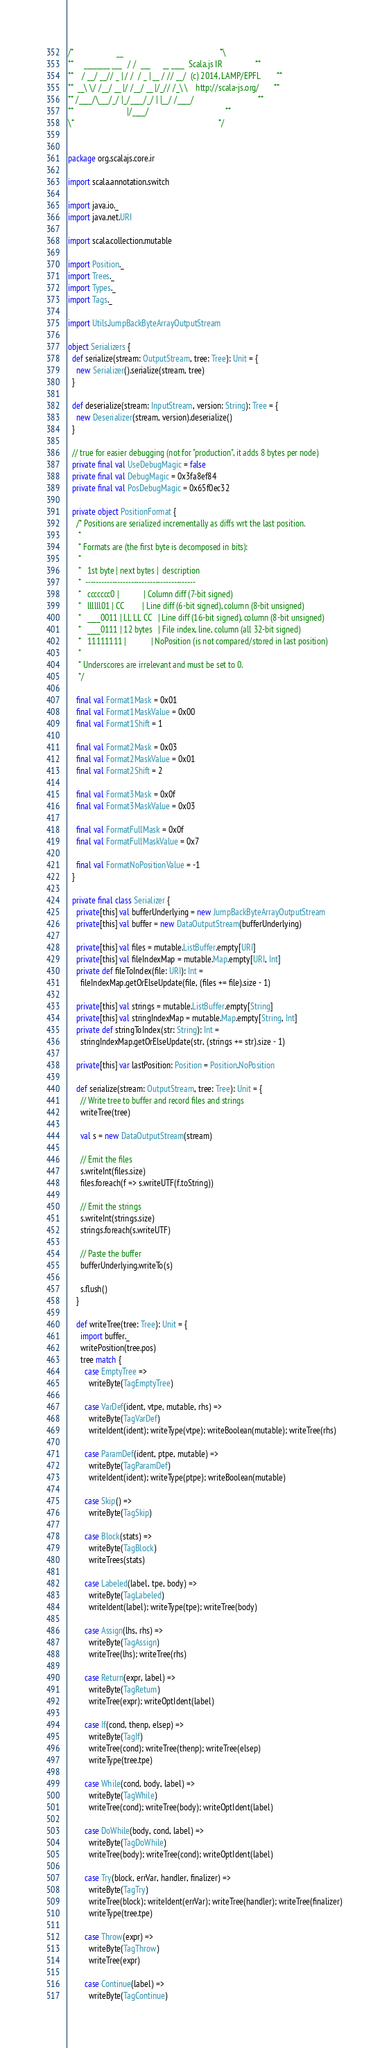<code> <loc_0><loc_0><loc_500><loc_500><_Scala_>/*                     __                                               *\
**     ________ ___   / /  ___      __ ____  Scala.js IR                **
**    / __/ __// _ | / /  / _ | __ / // __/  (c) 2014, LAMP/EPFL        **
**  __\ \/ /__/ __ |/ /__/ __ |/_// /_\ \    http://scala-js.org/       **
** /____/\___/_/ |_/____/_/ | |__/ /____/                               **
**                          |/____/                                     **
\*                                                                      */


package org.scalajs.core.ir

import scala.annotation.switch

import java.io._
import java.net.URI

import scala.collection.mutable

import Position._
import Trees._
import Types._
import Tags._

import Utils.JumpBackByteArrayOutputStream

object Serializers {
  def serialize(stream: OutputStream, tree: Tree): Unit = {
    new Serializer().serialize(stream, tree)
  }

  def deserialize(stream: InputStream, version: String): Tree = {
    new Deserializer(stream, version).deserialize()
  }

  // true for easier debugging (not for "production", it adds 8 bytes per node)
  private final val UseDebugMagic = false
  private final val DebugMagic = 0x3fa8ef84
  private final val PosDebugMagic = 0x65f0ec32

  private object PositionFormat {
    /* Positions are serialized incrementally as diffs wrt the last position.
     *
     * Formats are (the first byte is decomposed in bits):
     *
     *   1st byte | next bytes |  description
     *  -----------------------------------------
     *   ccccccc0 |            | Column diff (7-bit signed)
     *   llllll01 | CC         | Line diff (6-bit signed), column (8-bit unsigned)
     *   ____0011 | LL LL CC   | Line diff (16-bit signed), column (8-bit unsigned)
     *   ____0111 | 12 bytes   | File index, line, column (all 32-bit signed)
     *   11111111 |            | NoPosition (is not compared/stored in last position)
     *
     * Underscores are irrelevant and must be set to 0.
     */

    final val Format1Mask = 0x01
    final val Format1MaskValue = 0x00
    final val Format1Shift = 1

    final val Format2Mask = 0x03
    final val Format2MaskValue = 0x01
    final val Format2Shift = 2

    final val Format3Mask = 0x0f
    final val Format3MaskValue = 0x03

    final val FormatFullMask = 0x0f
    final val FormatFullMaskValue = 0x7

    final val FormatNoPositionValue = -1
  }

  private final class Serializer {
    private[this] val bufferUnderlying = new JumpBackByteArrayOutputStream
    private[this] val buffer = new DataOutputStream(bufferUnderlying)

    private[this] val files = mutable.ListBuffer.empty[URI]
    private[this] val fileIndexMap = mutable.Map.empty[URI, Int]
    private def fileToIndex(file: URI): Int =
      fileIndexMap.getOrElseUpdate(file, (files += file).size - 1)

    private[this] val strings = mutable.ListBuffer.empty[String]
    private[this] val stringIndexMap = mutable.Map.empty[String, Int]
    private def stringToIndex(str: String): Int =
      stringIndexMap.getOrElseUpdate(str, (strings += str).size - 1)

    private[this] var lastPosition: Position = Position.NoPosition

    def serialize(stream: OutputStream, tree: Tree): Unit = {
      // Write tree to buffer and record files and strings
      writeTree(tree)

      val s = new DataOutputStream(stream)

      // Emit the files
      s.writeInt(files.size)
      files.foreach(f => s.writeUTF(f.toString))

      // Emit the strings
      s.writeInt(strings.size)
      strings.foreach(s.writeUTF)

      // Paste the buffer
      bufferUnderlying.writeTo(s)

      s.flush()
    }

    def writeTree(tree: Tree): Unit = {
      import buffer._
      writePosition(tree.pos)
      tree match {
        case EmptyTree =>
          writeByte(TagEmptyTree)

        case VarDef(ident, vtpe, mutable, rhs) =>
          writeByte(TagVarDef)
          writeIdent(ident); writeType(vtpe); writeBoolean(mutable); writeTree(rhs)

        case ParamDef(ident, ptpe, mutable) =>
          writeByte(TagParamDef)
          writeIdent(ident); writeType(ptpe); writeBoolean(mutable)

        case Skip() =>
          writeByte(TagSkip)

        case Block(stats) =>
          writeByte(TagBlock)
          writeTrees(stats)

        case Labeled(label, tpe, body) =>
          writeByte(TagLabeled)
          writeIdent(label); writeType(tpe); writeTree(body)

        case Assign(lhs, rhs) =>
          writeByte(TagAssign)
          writeTree(lhs); writeTree(rhs)

        case Return(expr, label) =>
          writeByte(TagReturn)
          writeTree(expr); writeOptIdent(label)

        case If(cond, thenp, elsep) =>
          writeByte(TagIf)
          writeTree(cond); writeTree(thenp); writeTree(elsep)
          writeType(tree.tpe)

        case While(cond, body, label) =>
          writeByte(TagWhile)
          writeTree(cond); writeTree(body); writeOptIdent(label)

        case DoWhile(body, cond, label) =>
          writeByte(TagDoWhile)
          writeTree(body); writeTree(cond); writeOptIdent(label)

        case Try(block, errVar, handler, finalizer) =>
          writeByte(TagTry)
          writeTree(block); writeIdent(errVar); writeTree(handler); writeTree(finalizer)
          writeType(tree.tpe)

        case Throw(expr) =>
          writeByte(TagThrow)
          writeTree(expr)

        case Continue(label) =>
          writeByte(TagContinue)</code> 